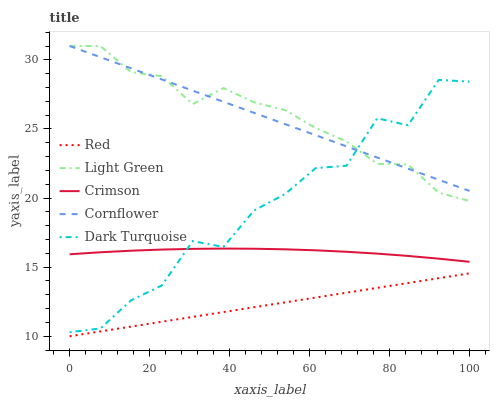Does Red have the minimum area under the curve?
Answer yes or no. Yes. Does Light Green have the maximum area under the curve?
Answer yes or no. Yes. Does Cornflower have the minimum area under the curve?
Answer yes or no. No. Does Cornflower have the maximum area under the curve?
Answer yes or no. No. Is Red the smoothest?
Answer yes or no. Yes. Is Dark Turquoise the roughest?
Answer yes or no. Yes. Is Cornflower the smoothest?
Answer yes or no. No. Is Cornflower the roughest?
Answer yes or no. No. Does Red have the lowest value?
Answer yes or no. Yes. Does Light Green have the lowest value?
Answer yes or no. No. Does Light Green have the highest value?
Answer yes or no. Yes. Does Red have the highest value?
Answer yes or no. No. Is Crimson less than Light Green?
Answer yes or no. Yes. Is Light Green greater than Red?
Answer yes or no. Yes. Does Cornflower intersect Dark Turquoise?
Answer yes or no. Yes. Is Cornflower less than Dark Turquoise?
Answer yes or no. No. Is Cornflower greater than Dark Turquoise?
Answer yes or no. No. Does Crimson intersect Light Green?
Answer yes or no. No. 